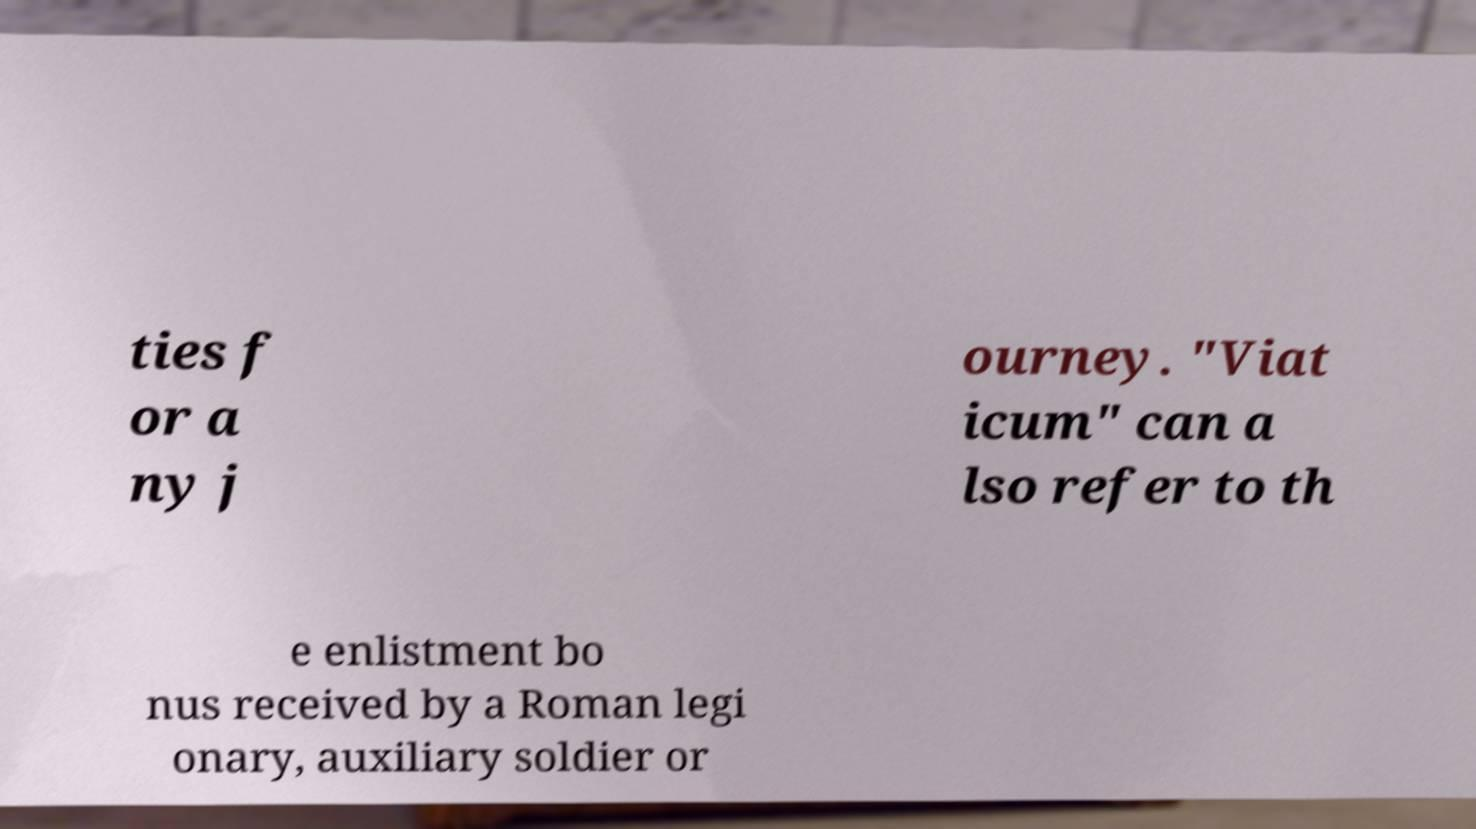Please identify and transcribe the text found in this image. ties f or a ny j ourney. "Viat icum" can a lso refer to th e enlistment bo nus received by a Roman legi onary, auxiliary soldier or 